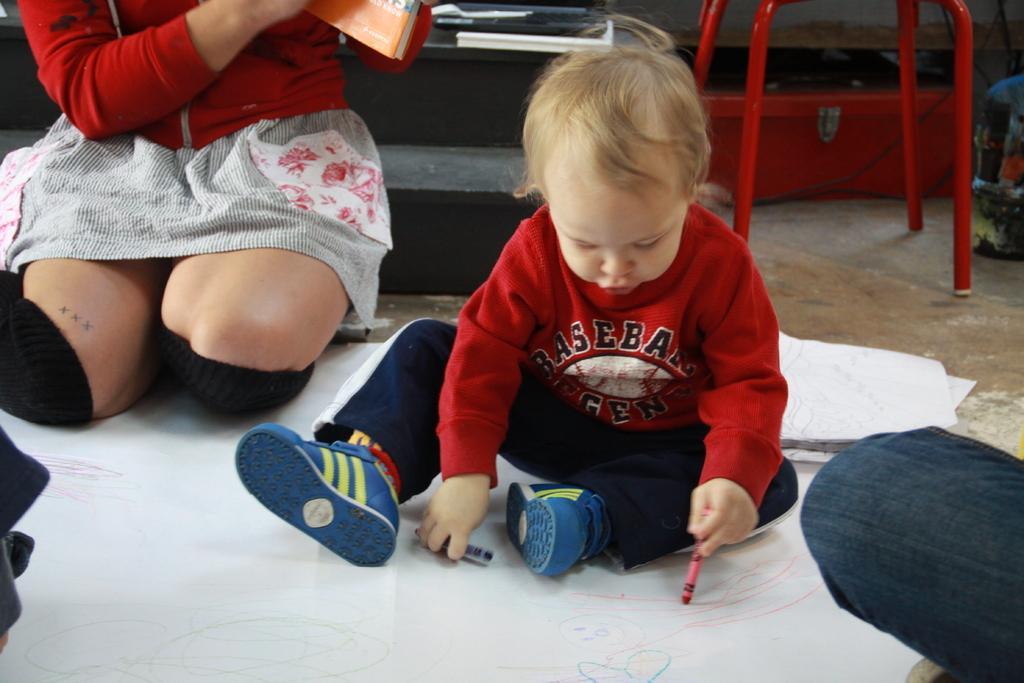How would you summarize this image in a sentence or two? There is a baby drawing on a white paper with crayons. Near to him there is a person sitting and holding a book. 